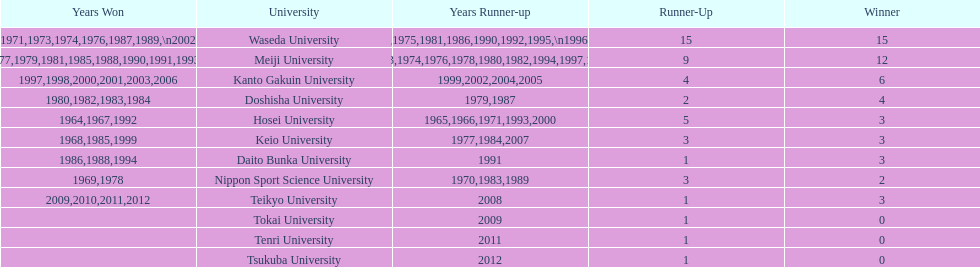Hosei won in 1964. who won the next year? Waseda University. 